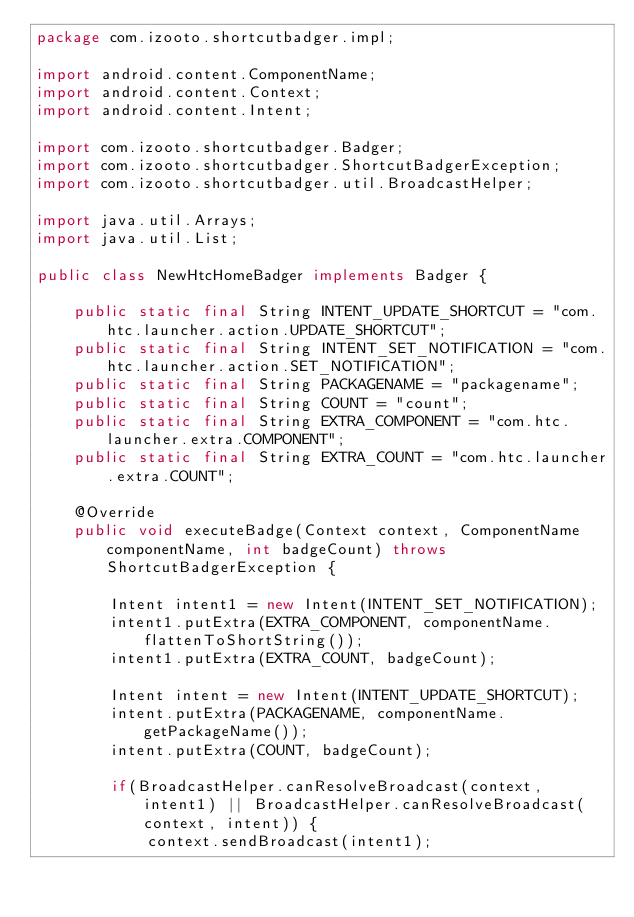<code> <loc_0><loc_0><loc_500><loc_500><_Java_>package com.izooto.shortcutbadger.impl;

import android.content.ComponentName;
import android.content.Context;
import android.content.Intent;

import com.izooto.shortcutbadger.Badger;
import com.izooto.shortcutbadger.ShortcutBadgerException;
import com.izooto.shortcutbadger.util.BroadcastHelper;

import java.util.Arrays;
import java.util.List;

public class NewHtcHomeBadger implements Badger {

    public static final String INTENT_UPDATE_SHORTCUT = "com.htc.launcher.action.UPDATE_SHORTCUT";
    public static final String INTENT_SET_NOTIFICATION = "com.htc.launcher.action.SET_NOTIFICATION";
    public static final String PACKAGENAME = "packagename";
    public static final String COUNT = "count";
    public static final String EXTRA_COMPONENT = "com.htc.launcher.extra.COMPONENT";
    public static final String EXTRA_COUNT = "com.htc.launcher.extra.COUNT";

    @Override
    public void executeBadge(Context context, ComponentName componentName, int badgeCount) throws ShortcutBadgerException {

        Intent intent1 = new Intent(INTENT_SET_NOTIFICATION);
        intent1.putExtra(EXTRA_COMPONENT, componentName.flattenToShortString());
        intent1.putExtra(EXTRA_COUNT, badgeCount);

        Intent intent = new Intent(INTENT_UPDATE_SHORTCUT);
        intent.putExtra(PACKAGENAME, componentName.getPackageName());
        intent.putExtra(COUNT, badgeCount);

        if(BroadcastHelper.canResolveBroadcast(context, intent1) || BroadcastHelper.canResolveBroadcast(context, intent)) {
            context.sendBroadcast(intent1);</code> 